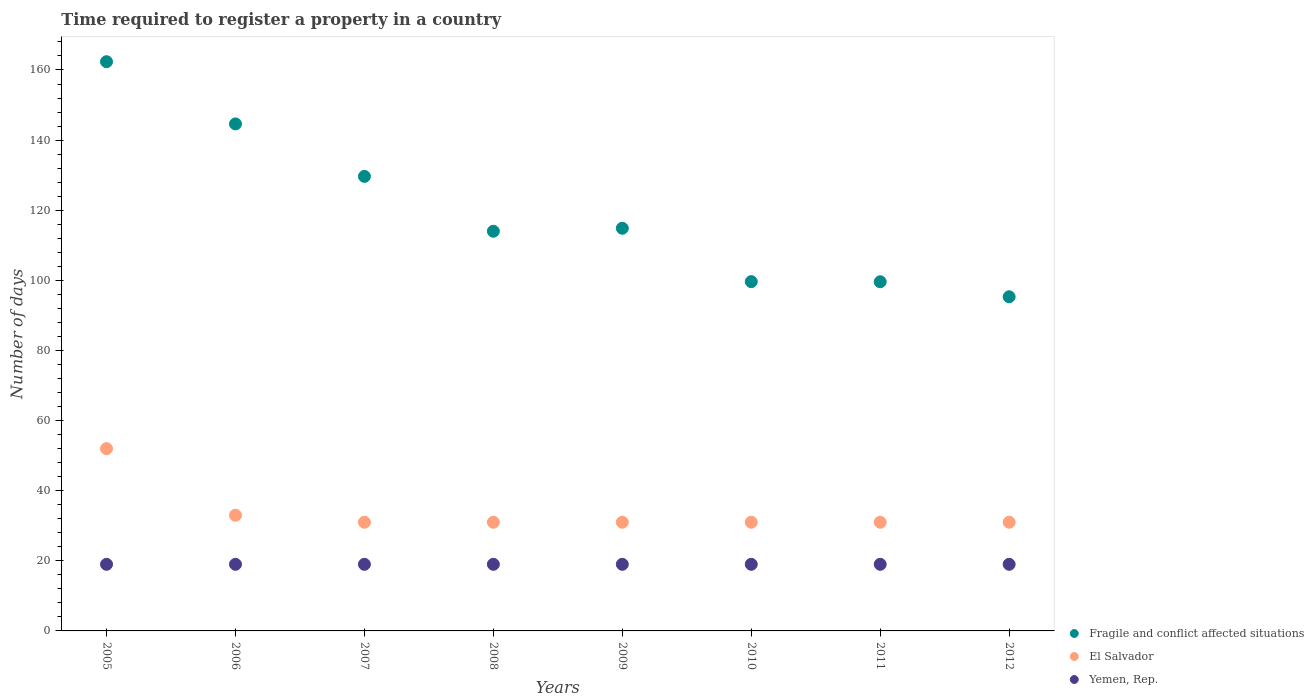How many different coloured dotlines are there?
Provide a short and direct response. 3. Is the number of dotlines equal to the number of legend labels?
Offer a very short reply. Yes. What is the number of days required to register a property in Fragile and conflict affected situations in 2006?
Your answer should be compact. 144.62. Across all years, what is the maximum number of days required to register a property in Fragile and conflict affected situations?
Your response must be concise. 162.36. Across all years, what is the minimum number of days required to register a property in Fragile and conflict affected situations?
Your response must be concise. 95.31. What is the total number of days required to register a property in Fragile and conflict affected situations in the graph?
Your answer should be compact. 960.01. What is the difference between the number of days required to register a property in Fragile and conflict affected situations in 2006 and that in 2010?
Your answer should be compact. 44.99. What is the difference between the number of days required to register a property in El Salvador in 2011 and the number of days required to register a property in Fragile and conflict affected situations in 2012?
Provide a short and direct response. -64.31. In how many years, is the number of days required to register a property in Yemen, Rep. greater than 156 days?
Give a very brief answer. 0. What is the difference between the highest and the second highest number of days required to register a property in Yemen, Rep.?
Your answer should be compact. 0. What is the difference between the highest and the lowest number of days required to register a property in El Salvador?
Give a very brief answer. 21. Is the sum of the number of days required to register a property in El Salvador in 2009 and 2010 greater than the maximum number of days required to register a property in Fragile and conflict affected situations across all years?
Your answer should be compact. No. Does the number of days required to register a property in Yemen, Rep. monotonically increase over the years?
Your answer should be very brief. No. Is the number of days required to register a property in El Salvador strictly less than the number of days required to register a property in Fragile and conflict affected situations over the years?
Provide a succinct answer. Yes. How many years are there in the graph?
Offer a terse response. 8. Does the graph contain grids?
Provide a short and direct response. No. Where does the legend appear in the graph?
Offer a very short reply. Bottom right. How many legend labels are there?
Your answer should be compact. 3. How are the legend labels stacked?
Give a very brief answer. Vertical. What is the title of the graph?
Ensure brevity in your answer.  Time required to register a property in a country. What is the label or title of the X-axis?
Keep it short and to the point. Years. What is the label or title of the Y-axis?
Offer a terse response. Number of days. What is the Number of days in Fragile and conflict affected situations in 2005?
Offer a very short reply. 162.36. What is the Number of days of Fragile and conflict affected situations in 2006?
Make the answer very short. 144.62. What is the Number of days of El Salvador in 2006?
Ensure brevity in your answer.  33. What is the Number of days of Yemen, Rep. in 2006?
Give a very brief answer. 19. What is the Number of days of Fragile and conflict affected situations in 2007?
Your answer should be very brief. 129.65. What is the Number of days of Yemen, Rep. in 2007?
Provide a short and direct response. 19. What is the Number of days of Fragile and conflict affected situations in 2008?
Provide a succinct answer. 114. What is the Number of days in Fragile and conflict affected situations in 2009?
Offer a very short reply. 114.85. What is the Number of days in Fragile and conflict affected situations in 2010?
Your response must be concise. 99.63. What is the Number of days of Yemen, Rep. in 2010?
Make the answer very short. 19. What is the Number of days of Fragile and conflict affected situations in 2011?
Your response must be concise. 99.59. What is the Number of days in El Salvador in 2011?
Your answer should be compact. 31. What is the Number of days of Fragile and conflict affected situations in 2012?
Ensure brevity in your answer.  95.31. What is the Number of days of El Salvador in 2012?
Your answer should be compact. 31. What is the Number of days in Yemen, Rep. in 2012?
Your answer should be compact. 19. Across all years, what is the maximum Number of days in Fragile and conflict affected situations?
Keep it short and to the point. 162.36. Across all years, what is the minimum Number of days in Fragile and conflict affected situations?
Provide a short and direct response. 95.31. Across all years, what is the minimum Number of days in El Salvador?
Provide a short and direct response. 31. What is the total Number of days of Fragile and conflict affected situations in the graph?
Your response must be concise. 960.01. What is the total Number of days of El Salvador in the graph?
Ensure brevity in your answer.  271. What is the total Number of days of Yemen, Rep. in the graph?
Offer a terse response. 152. What is the difference between the Number of days of Fragile and conflict affected situations in 2005 and that in 2006?
Offer a very short reply. 17.74. What is the difference between the Number of days in El Salvador in 2005 and that in 2006?
Provide a short and direct response. 19. What is the difference between the Number of days of Fragile and conflict affected situations in 2005 and that in 2007?
Provide a succinct answer. 32.71. What is the difference between the Number of days of El Salvador in 2005 and that in 2007?
Provide a short and direct response. 21. What is the difference between the Number of days in Fragile and conflict affected situations in 2005 and that in 2008?
Make the answer very short. 48.36. What is the difference between the Number of days in Yemen, Rep. in 2005 and that in 2008?
Provide a short and direct response. 0. What is the difference between the Number of days of Fragile and conflict affected situations in 2005 and that in 2009?
Ensure brevity in your answer.  47.51. What is the difference between the Number of days in El Salvador in 2005 and that in 2009?
Provide a short and direct response. 21. What is the difference between the Number of days in Yemen, Rep. in 2005 and that in 2009?
Make the answer very short. 0. What is the difference between the Number of days in Fragile and conflict affected situations in 2005 and that in 2010?
Provide a short and direct response. 62.73. What is the difference between the Number of days of Fragile and conflict affected situations in 2005 and that in 2011?
Offer a terse response. 62.77. What is the difference between the Number of days of Yemen, Rep. in 2005 and that in 2011?
Ensure brevity in your answer.  0. What is the difference between the Number of days of Fragile and conflict affected situations in 2005 and that in 2012?
Keep it short and to the point. 67.05. What is the difference between the Number of days in Fragile and conflict affected situations in 2006 and that in 2007?
Give a very brief answer. 14.96. What is the difference between the Number of days of El Salvador in 2006 and that in 2007?
Offer a very short reply. 2. What is the difference between the Number of days of Yemen, Rep. in 2006 and that in 2007?
Make the answer very short. 0. What is the difference between the Number of days of Fragile and conflict affected situations in 2006 and that in 2008?
Offer a very short reply. 30.62. What is the difference between the Number of days in Yemen, Rep. in 2006 and that in 2008?
Provide a succinct answer. 0. What is the difference between the Number of days of Fragile and conflict affected situations in 2006 and that in 2009?
Offer a very short reply. 29.76. What is the difference between the Number of days in El Salvador in 2006 and that in 2009?
Provide a short and direct response. 2. What is the difference between the Number of days of Yemen, Rep. in 2006 and that in 2009?
Provide a succinct answer. 0. What is the difference between the Number of days in Fragile and conflict affected situations in 2006 and that in 2010?
Provide a short and direct response. 44.99. What is the difference between the Number of days of Fragile and conflict affected situations in 2006 and that in 2011?
Offer a very short reply. 45.02. What is the difference between the Number of days in Fragile and conflict affected situations in 2006 and that in 2012?
Your answer should be compact. 49.3. What is the difference between the Number of days of El Salvador in 2006 and that in 2012?
Offer a very short reply. 2. What is the difference between the Number of days in Yemen, Rep. in 2006 and that in 2012?
Your response must be concise. 0. What is the difference between the Number of days in Fragile and conflict affected situations in 2007 and that in 2008?
Provide a succinct answer. 15.65. What is the difference between the Number of days in Fragile and conflict affected situations in 2007 and that in 2009?
Give a very brief answer. 14.8. What is the difference between the Number of days in Fragile and conflict affected situations in 2007 and that in 2010?
Ensure brevity in your answer.  30.02. What is the difference between the Number of days of El Salvador in 2007 and that in 2010?
Offer a terse response. 0. What is the difference between the Number of days of Fragile and conflict affected situations in 2007 and that in 2011?
Make the answer very short. 30.06. What is the difference between the Number of days in El Salvador in 2007 and that in 2011?
Your answer should be compact. 0. What is the difference between the Number of days in Fragile and conflict affected situations in 2007 and that in 2012?
Make the answer very short. 34.34. What is the difference between the Number of days of Fragile and conflict affected situations in 2008 and that in 2009?
Your answer should be very brief. -0.85. What is the difference between the Number of days in Fragile and conflict affected situations in 2008 and that in 2010?
Offer a very short reply. 14.37. What is the difference between the Number of days in El Salvador in 2008 and that in 2010?
Your answer should be very brief. 0. What is the difference between the Number of days of Fragile and conflict affected situations in 2008 and that in 2011?
Give a very brief answer. 14.41. What is the difference between the Number of days of Yemen, Rep. in 2008 and that in 2011?
Your answer should be compact. 0. What is the difference between the Number of days in Fragile and conflict affected situations in 2008 and that in 2012?
Make the answer very short. 18.69. What is the difference between the Number of days in Yemen, Rep. in 2008 and that in 2012?
Make the answer very short. 0. What is the difference between the Number of days of Fragile and conflict affected situations in 2009 and that in 2010?
Keep it short and to the point. 15.22. What is the difference between the Number of days of Fragile and conflict affected situations in 2009 and that in 2011?
Ensure brevity in your answer.  15.26. What is the difference between the Number of days in El Salvador in 2009 and that in 2011?
Your answer should be compact. 0. What is the difference between the Number of days of Yemen, Rep. in 2009 and that in 2011?
Provide a succinct answer. 0. What is the difference between the Number of days in Fragile and conflict affected situations in 2009 and that in 2012?
Your answer should be compact. 19.54. What is the difference between the Number of days of Yemen, Rep. in 2009 and that in 2012?
Give a very brief answer. 0. What is the difference between the Number of days in Fragile and conflict affected situations in 2010 and that in 2011?
Offer a very short reply. 0.04. What is the difference between the Number of days of El Salvador in 2010 and that in 2011?
Provide a short and direct response. 0. What is the difference between the Number of days in Yemen, Rep. in 2010 and that in 2011?
Provide a succinct answer. 0. What is the difference between the Number of days in Fragile and conflict affected situations in 2010 and that in 2012?
Offer a terse response. 4.32. What is the difference between the Number of days of El Salvador in 2010 and that in 2012?
Provide a succinct answer. 0. What is the difference between the Number of days in Yemen, Rep. in 2010 and that in 2012?
Offer a very short reply. 0. What is the difference between the Number of days in Fragile and conflict affected situations in 2011 and that in 2012?
Provide a short and direct response. 4.28. What is the difference between the Number of days in El Salvador in 2011 and that in 2012?
Ensure brevity in your answer.  0. What is the difference between the Number of days in Fragile and conflict affected situations in 2005 and the Number of days in El Salvador in 2006?
Offer a very short reply. 129.36. What is the difference between the Number of days of Fragile and conflict affected situations in 2005 and the Number of days of Yemen, Rep. in 2006?
Provide a succinct answer. 143.36. What is the difference between the Number of days of Fragile and conflict affected situations in 2005 and the Number of days of El Salvador in 2007?
Offer a terse response. 131.36. What is the difference between the Number of days of Fragile and conflict affected situations in 2005 and the Number of days of Yemen, Rep. in 2007?
Offer a terse response. 143.36. What is the difference between the Number of days in El Salvador in 2005 and the Number of days in Yemen, Rep. in 2007?
Offer a terse response. 33. What is the difference between the Number of days in Fragile and conflict affected situations in 2005 and the Number of days in El Salvador in 2008?
Your answer should be very brief. 131.36. What is the difference between the Number of days of Fragile and conflict affected situations in 2005 and the Number of days of Yemen, Rep. in 2008?
Offer a terse response. 143.36. What is the difference between the Number of days of Fragile and conflict affected situations in 2005 and the Number of days of El Salvador in 2009?
Your answer should be very brief. 131.36. What is the difference between the Number of days in Fragile and conflict affected situations in 2005 and the Number of days in Yemen, Rep. in 2009?
Provide a succinct answer. 143.36. What is the difference between the Number of days of El Salvador in 2005 and the Number of days of Yemen, Rep. in 2009?
Your response must be concise. 33. What is the difference between the Number of days of Fragile and conflict affected situations in 2005 and the Number of days of El Salvador in 2010?
Keep it short and to the point. 131.36. What is the difference between the Number of days of Fragile and conflict affected situations in 2005 and the Number of days of Yemen, Rep. in 2010?
Give a very brief answer. 143.36. What is the difference between the Number of days of El Salvador in 2005 and the Number of days of Yemen, Rep. in 2010?
Keep it short and to the point. 33. What is the difference between the Number of days of Fragile and conflict affected situations in 2005 and the Number of days of El Salvador in 2011?
Keep it short and to the point. 131.36. What is the difference between the Number of days in Fragile and conflict affected situations in 2005 and the Number of days in Yemen, Rep. in 2011?
Your response must be concise. 143.36. What is the difference between the Number of days in Fragile and conflict affected situations in 2005 and the Number of days in El Salvador in 2012?
Make the answer very short. 131.36. What is the difference between the Number of days of Fragile and conflict affected situations in 2005 and the Number of days of Yemen, Rep. in 2012?
Your answer should be very brief. 143.36. What is the difference between the Number of days in Fragile and conflict affected situations in 2006 and the Number of days in El Salvador in 2007?
Give a very brief answer. 113.62. What is the difference between the Number of days of Fragile and conflict affected situations in 2006 and the Number of days of Yemen, Rep. in 2007?
Your answer should be compact. 125.62. What is the difference between the Number of days in Fragile and conflict affected situations in 2006 and the Number of days in El Salvador in 2008?
Your answer should be compact. 113.62. What is the difference between the Number of days in Fragile and conflict affected situations in 2006 and the Number of days in Yemen, Rep. in 2008?
Provide a short and direct response. 125.62. What is the difference between the Number of days in El Salvador in 2006 and the Number of days in Yemen, Rep. in 2008?
Offer a terse response. 14. What is the difference between the Number of days of Fragile and conflict affected situations in 2006 and the Number of days of El Salvador in 2009?
Your answer should be very brief. 113.62. What is the difference between the Number of days in Fragile and conflict affected situations in 2006 and the Number of days in Yemen, Rep. in 2009?
Keep it short and to the point. 125.62. What is the difference between the Number of days of Fragile and conflict affected situations in 2006 and the Number of days of El Salvador in 2010?
Your answer should be compact. 113.62. What is the difference between the Number of days in Fragile and conflict affected situations in 2006 and the Number of days in Yemen, Rep. in 2010?
Keep it short and to the point. 125.62. What is the difference between the Number of days of Fragile and conflict affected situations in 2006 and the Number of days of El Salvador in 2011?
Make the answer very short. 113.62. What is the difference between the Number of days of Fragile and conflict affected situations in 2006 and the Number of days of Yemen, Rep. in 2011?
Give a very brief answer. 125.62. What is the difference between the Number of days in El Salvador in 2006 and the Number of days in Yemen, Rep. in 2011?
Your response must be concise. 14. What is the difference between the Number of days in Fragile and conflict affected situations in 2006 and the Number of days in El Salvador in 2012?
Ensure brevity in your answer.  113.62. What is the difference between the Number of days of Fragile and conflict affected situations in 2006 and the Number of days of Yemen, Rep. in 2012?
Ensure brevity in your answer.  125.62. What is the difference between the Number of days of Fragile and conflict affected situations in 2007 and the Number of days of El Salvador in 2008?
Ensure brevity in your answer.  98.65. What is the difference between the Number of days of Fragile and conflict affected situations in 2007 and the Number of days of Yemen, Rep. in 2008?
Your answer should be compact. 110.65. What is the difference between the Number of days of Fragile and conflict affected situations in 2007 and the Number of days of El Salvador in 2009?
Make the answer very short. 98.65. What is the difference between the Number of days in Fragile and conflict affected situations in 2007 and the Number of days in Yemen, Rep. in 2009?
Keep it short and to the point. 110.65. What is the difference between the Number of days of Fragile and conflict affected situations in 2007 and the Number of days of El Salvador in 2010?
Offer a very short reply. 98.65. What is the difference between the Number of days of Fragile and conflict affected situations in 2007 and the Number of days of Yemen, Rep. in 2010?
Your answer should be compact. 110.65. What is the difference between the Number of days of Fragile and conflict affected situations in 2007 and the Number of days of El Salvador in 2011?
Offer a terse response. 98.65. What is the difference between the Number of days of Fragile and conflict affected situations in 2007 and the Number of days of Yemen, Rep. in 2011?
Offer a very short reply. 110.65. What is the difference between the Number of days of Fragile and conflict affected situations in 2007 and the Number of days of El Salvador in 2012?
Make the answer very short. 98.65. What is the difference between the Number of days of Fragile and conflict affected situations in 2007 and the Number of days of Yemen, Rep. in 2012?
Offer a very short reply. 110.65. What is the difference between the Number of days in El Salvador in 2008 and the Number of days in Yemen, Rep. in 2009?
Ensure brevity in your answer.  12. What is the difference between the Number of days in Fragile and conflict affected situations in 2008 and the Number of days in Yemen, Rep. in 2010?
Provide a succinct answer. 95. What is the difference between the Number of days in Fragile and conflict affected situations in 2008 and the Number of days in El Salvador in 2011?
Ensure brevity in your answer.  83. What is the difference between the Number of days in Fragile and conflict affected situations in 2008 and the Number of days in Yemen, Rep. in 2011?
Your response must be concise. 95. What is the difference between the Number of days in El Salvador in 2008 and the Number of days in Yemen, Rep. in 2012?
Your answer should be compact. 12. What is the difference between the Number of days in Fragile and conflict affected situations in 2009 and the Number of days in El Salvador in 2010?
Offer a terse response. 83.85. What is the difference between the Number of days in Fragile and conflict affected situations in 2009 and the Number of days in Yemen, Rep. in 2010?
Keep it short and to the point. 95.85. What is the difference between the Number of days of El Salvador in 2009 and the Number of days of Yemen, Rep. in 2010?
Provide a succinct answer. 12. What is the difference between the Number of days in Fragile and conflict affected situations in 2009 and the Number of days in El Salvador in 2011?
Ensure brevity in your answer.  83.85. What is the difference between the Number of days in Fragile and conflict affected situations in 2009 and the Number of days in Yemen, Rep. in 2011?
Give a very brief answer. 95.85. What is the difference between the Number of days of El Salvador in 2009 and the Number of days of Yemen, Rep. in 2011?
Keep it short and to the point. 12. What is the difference between the Number of days in Fragile and conflict affected situations in 2009 and the Number of days in El Salvador in 2012?
Keep it short and to the point. 83.85. What is the difference between the Number of days in Fragile and conflict affected situations in 2009 and the Number of days in Yemen, Rep. in 2012?
Offer a terse response. 95.85. What is the difference between the Number of days of El Salvador in 2009 and the Number of days of Yemen, Rep. in 2012?
Keep it short and to the point. 12. What is the difference between the Number of days of Fragile and conflict affected situations in 2010 and the Number of days of El Salvador in 2011?
Your answer should be compact. 68.63. What is the difference between the Number of days of Fragile and conflict affected situations in 2010 and the Number of days of Yemen, Rep. in 2011?
Offer a terse response. 80.63. What is the difference between the Number of days in Fragile and conflict affected situations in 2010 and the Number of days in El Salvador in 2012?
Provide a short and direct response. 68.63. What is the difference between the Number of days of Fragile and conflict affected situations in 2010 and the Number of days of Yemen, Rep. in 2012?
Your answer should be compact. 80.63. What is the difference between the Number of days of El Salvador in 2010 and the Number of days of Yemen, Rep. in 2012?
Give a very brief answer. 12. What is the difference between the Number of days of Fragile and conflict affected situations in 2011 and the Number of days of El Salvador in 2012?
Provide a short and direct response. 68.59. What is the difference between the Number of days of Fragile and conflict affected situations in 2011 and the Number of days of Yemen, Rep. in 2012?
Make the answer very short. 80.59. What is the average Number of days of Fragile and conflict affected situations per year?
Keep it short and to the point. 120. What is the average Number of days of El Salvador per year?
Your response must be concise. 33.88. What is the average Number of days in Yemen, Rep. per year?
Make the answer very short. 19. In the year 2005, what is the difference between the Number of days in Fragile and conflict affected situations and Number of days in El Salvador?
Offer a very short reply. 110.36. In the year 2005, what is the difference between the Number of days of Fragile and conflict affected situations and Number of days of Yemen, Rep.?
Offer a very short reply. 143.36. In the year 2006, what is the difference between the Number of days in Fragile and conflict affected situations and Number of days in El Salvador?
Your response must be concise. 111.62. In the year 2006, what is the difference between the Number of days of Fragile and conflict affected situations and Number of days of Yemen, Rep.?
Offer a terse response. 125.62. In the year 2006, what is the difference between the Number of days in El Salvador and Number of days in Yemen, Rep.?
Keep it short and to the point. 14. In the year 2007, what is the difference between the Number of days in Fragile and conflict affected situations and Number of days in El Salvador?
Ensure brevity in your answer.  98.65. In the year 2007, what is the difference between the Number of days of Fragile and conflict affected situations and Number of days of Yemen, Rep.?
Your answer should be compact. 110.65. In the year 2008, what is the difference between the Number of days of Fragile and conflict affected situations and Number of days of Yemen, Rep.?
Ensure brevity in your answer.  95. In the year 2009, what is the difference between the Number of days of Fragile and conflict affected situations and Number of days of El Salvador?
Offer a very short reply. 83.85. In the year 2009, what is the difference between the Number of days in Fragile and conflict affected situations and Number of days in Yemen, Rep.?
Provide a succinct answer. 95.85. In the year 2010, what is the difference between the Number of days in Fragile and conflict affected situations and Number of days in El Salvador?
Your response must be concise. 68.63. In the year 2010, what is the difference between the Number of days in Fragile and conflict affected situations and Number of days in Yemen, Rep.?
Offer a very short reply. 80.63. In the year 2011, what is the difference between the Number of days in Fragile and conflict affected situations and Number of days in El Salvador?
Provide a succinct answer. 68.59. In the year 2011, what is the difference between the Number of days of Fragile and conflict affected situations and Number of days of Yemen, Rep.?
Offer a very short reply. 80.59. In the year 2011, what is the difference between the Number of days of El Salvador and Number of days of Yemen, Rep.?
Provide a short and direct response. 12. In the year 2012, what is the difference between the Number of days in Fragile and conflict affected situations and Number of days in El Salvador?
Give a very brief answer. 64.31. In the year 2012, what is the difference between the Number of days of Fragile and conflict affected situations and Number of days of Yemen, Rep.?
Keep it short and to the point. 76.31. What is the ratio of the Number of days in Fragile and conflict affected situations in 2005 to that in 2006?
Your response must be concise. 1.12. What is the ratio of the Number of days of El Salvador in 2005 to that in 2006?
Your answer should be very brief. 1.58. What is the ratio of the Number of days of Yemen, Rep. in 2005 to that in 2006?
Your answer should be compact. 1. What is the ratio of the Number of days of Fragile and conflict affected situations in 2005 to that in 2007?
Make the answer very short. 1.25. What is the ratio of the Number of days of El Salvador in 2005 to that in 2007?
Your response must be concise. 1.68. What is the ratio of the Number of days in Fragile and conflict affected situations in 2005 to that in 2008?
Provide a short and direct response. 1.42. What is the ratio of the Number of days of El Salvador in 2005 to that in 2008?
Give a very brief answer. 1.68. What is the ratio of the Number of days in Fragile and conflict affected situations in 2005 to that in 2009?
Keep it short and to the point. 1.41. What is the ratio of the Number of days in El Salvador in 2005 to that in 2009?
Give a very brief answer. 1.68. What is the ratio of the Number of days of Yemen, Rep. in 2005 to that in 2009?
Provide a short and direct response. 1. What is the ratio of the Number of days in Fragile and conflict affected situations in 2005 to that in 2010?
Give a very brief answer. 1.63. What is the ratio of the Number of days in El Salvador in 2005 to that in 2010?
Your answer should be very brief. 1.68. What is the ratio of the Number of days in Yemen, Rep. in 2005 to that in 2010?
Give a very brief answer. 1. What is the ratio of the Number of days of Fragile and conflict affected situations in 2005 to that in 2011?
Provide a succinct answer. 1.63. What is the ratio of the Number of days of El Salvador in 2005 to that in 2011?
Your response must be concise. 1.68. What is the ratio of the Number of days of Fragile and conflict affected situations in 2005 to that in 2012?
Give a very brief answer. 1.7. What is the ratio of the Number of days in El Salvador in 2005 to that in 2012?
Your answer should be compact. 1.68. What is the ratio of the Number of days in Yemen, Rep. in 2005 to that in 2012?
Give a very brief answer. 1. What is the ratio of the Number of days in Fragile and conflict affected situations in 2006 to that in 2007?
Your answer should be very brief. 1.12. What is the ratio of the Number of days of El Salvador in 2006 to that in 2007?
Give a very brief answer. 1.06. What is the ratio of the Number of days of Fragile and conflict affected situations in 2006 to that in 2008?
Provide a short and direct response. 1.27. What is the ratio of the Number of days of El Salvador in 2006 to that in 2008?
Your answer should be very brief. 1.06. What is the ratio of the Number of days of Yemen, Rep. in 2006 to that in 2008?
Offer a very short reply. 1. What is the ratio of the Number of days of Fragile and conflict affected situations in 2006 to that in 2009?
Your response must be concise. 1.26. What is the ratio of the Number of days in El Salvador in 2006 to that in 2009?
Provide a short and direct response. 1.06. What is the ratio of the Number of days in Fragile and conflict affected situations in 2006 to that in 2010?
Provide a succinct answer. 1.45. What is the ratio of the Number of days of El Salvador in 2006 to that in 2010?
Your answer should be very brief. 1.06. What is the ratio of the Number of days of Yemen, Rep. in 2006 to that in 2010?
Keep it short and to the point. 1. What is the ratio of the Number of days in Fragile and conflict affected situations in 2006 to that in 2011?
Your response must be concise. 1.45. What is the ratio of the Number of days in El Salvador in 2006 to that in 2011?
Provide a short and direct response. 1.06. What is the ratio of the Number of days of Yemen, Rep. in 2006 to that in 2011?
Provide a short and direct response. 1. What is the ratio of the Number of days in Fragile and conflict affected situations in 2006 to that in 2012?
Give a very brief answer. 1.52. What is the ratio of the Number of days in El Salvador in 2006 to that in 2012?
Make the answer very short. 1.06. What is the ratio of the Number of days of Fragile and conflict affected situations in 2007 to that in 2008?
Your answer should be compact. 1.14. What is the ratio of the Number of days of Fragile and conflict affected situations in 2007 to that in 2009?
Provide a short and direct response. 1.13. What is the ratio of the Number of days of Yemen, Rep. in 2007 to that in 2009?
Make the answer very short. 1. What is the ratio of the Number of days of Fragile and conflict affected situations in 2007 to that in 2010?
Keep it short and to the point. 1.3. What is the ratio of the Number of days in Fragile and conflict affected situations in 2007 to that in 2011?
Provide a succinct answer. 1.3. What is the ratio of the Number of days of Fragile and conflict affected situations in 2007 to that in 2012?
Provide a short and direct response. 1.36. What is the ratio of the Number of days in El Salvador in 2007 to that in 2012?
Ensure brevity in your answer.  1. What is the ratio of the Number of days in Yemen, Rep. in 2007 to that in 2012?
Keep it short and to the point. 1. What is the ratio of the Number of days of El Salvador in 2008 to that in 2009?
Offer a very short reply. 1. What is the ratio of the Number of days of Fragile and conflict affected situations in 2008 to that in 2010?
Give a very brief answer. 1.14. What is the ratio of the Number of days of El Salvador in 2008 to that in 2010?
Your answer should be very brief. 1. What is the ratio of the Number of days of Yemen, Rep. in 2008 to that in 2010?
Offer a very short reply. 1. What is the ratio of the Number of days of Fragile and conflict affected situations in 2008 to that in 2011?
Your answer should be very brief. 1.14. What is the ratio of the Number of days of El Salvador in 2008 to that in 2011?
Provide a succinct answer. 1. What is the ratio of the Number of days of Fragile and conflict affected situations in 2008 to that in 2012?
Make the answer very short. 1.2. What is the ratio of the Number of days in Fragile and conflict affected situations in 2009 to that in 2010?
Your answer should be very brief. 1.15. What is the ratio of the Number of days in El Salvador in 2009 to that in 2010?
Ensure brevity in your answer.  1. What is the ratio of the Number of days in Yemen, Rep. in 2009 to that in 2010?
Your response must be concise. 1. What is the ratio of the Number of days in Fragile and conflict affected situations in 2009 to that in 2011?
Ensure brevity in your answer.  1.15. What is the ratio of the Number of days in Yemen, Rep. in 2009 to that in 2011?
Your response must be concise. 1. What is the ratio of the Number of days of Fragile and conflict affected situations in 2009 to that in 2012?
Your response must be concise. 1.21. What is the ratio of the Number of days in Yemen, Rep. in 2009 to that in 2012?
Offer a terse response. 1. What is the ratio of the Number of days in Fragile and conflict affected situations in 2010 to that in 2011?
Your answer should be compact. 1. What is the ratio of the Number of days in Fragile and conflict affected situations in 2010 to that in 2012?
Your answer should be compact. 1.05. What is the ratio of the Number of days of Fragile and conflict affected situations in 2011 to that in 2012?
Your response must be concise. 1.04. What is the ratio of the Number of days of Yemen, Rep. in 2011 to that in 2012?
Provide a short and direct response. 1. What is the difference between the highest and the second highest Number of days in Fragile and conflict affected situations?
Make the answer very short. 17.74. What is the difference between the highest and the lowest Number of days in Fragile and conflict affected situations?
Ensure brevity in your answer.  67.05. 